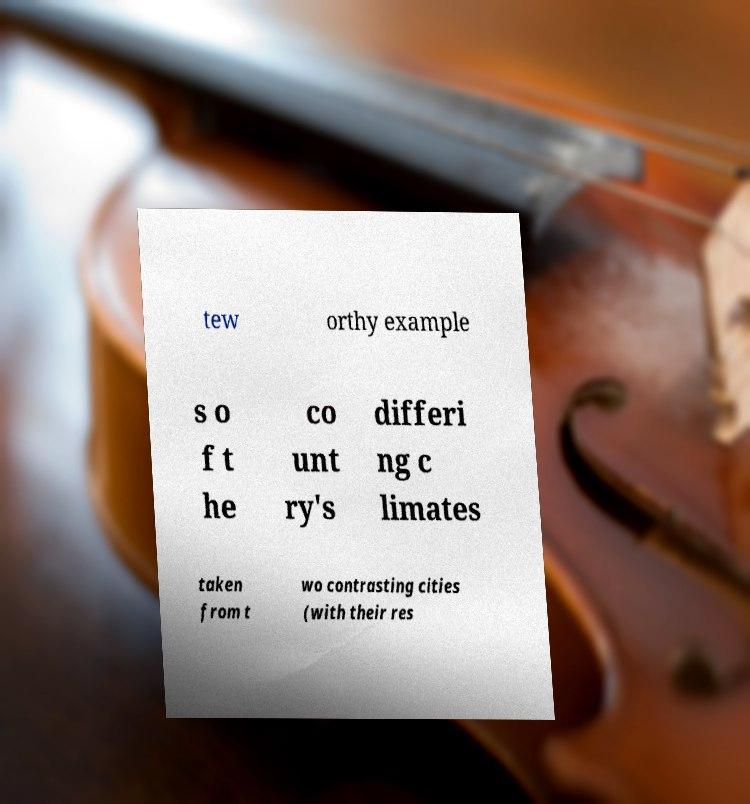Please identify and transcribe the text found in this image. tew orthy example s o f t he co unt ry's differi ng c limates taken from t wo contrasting cities (with their res 